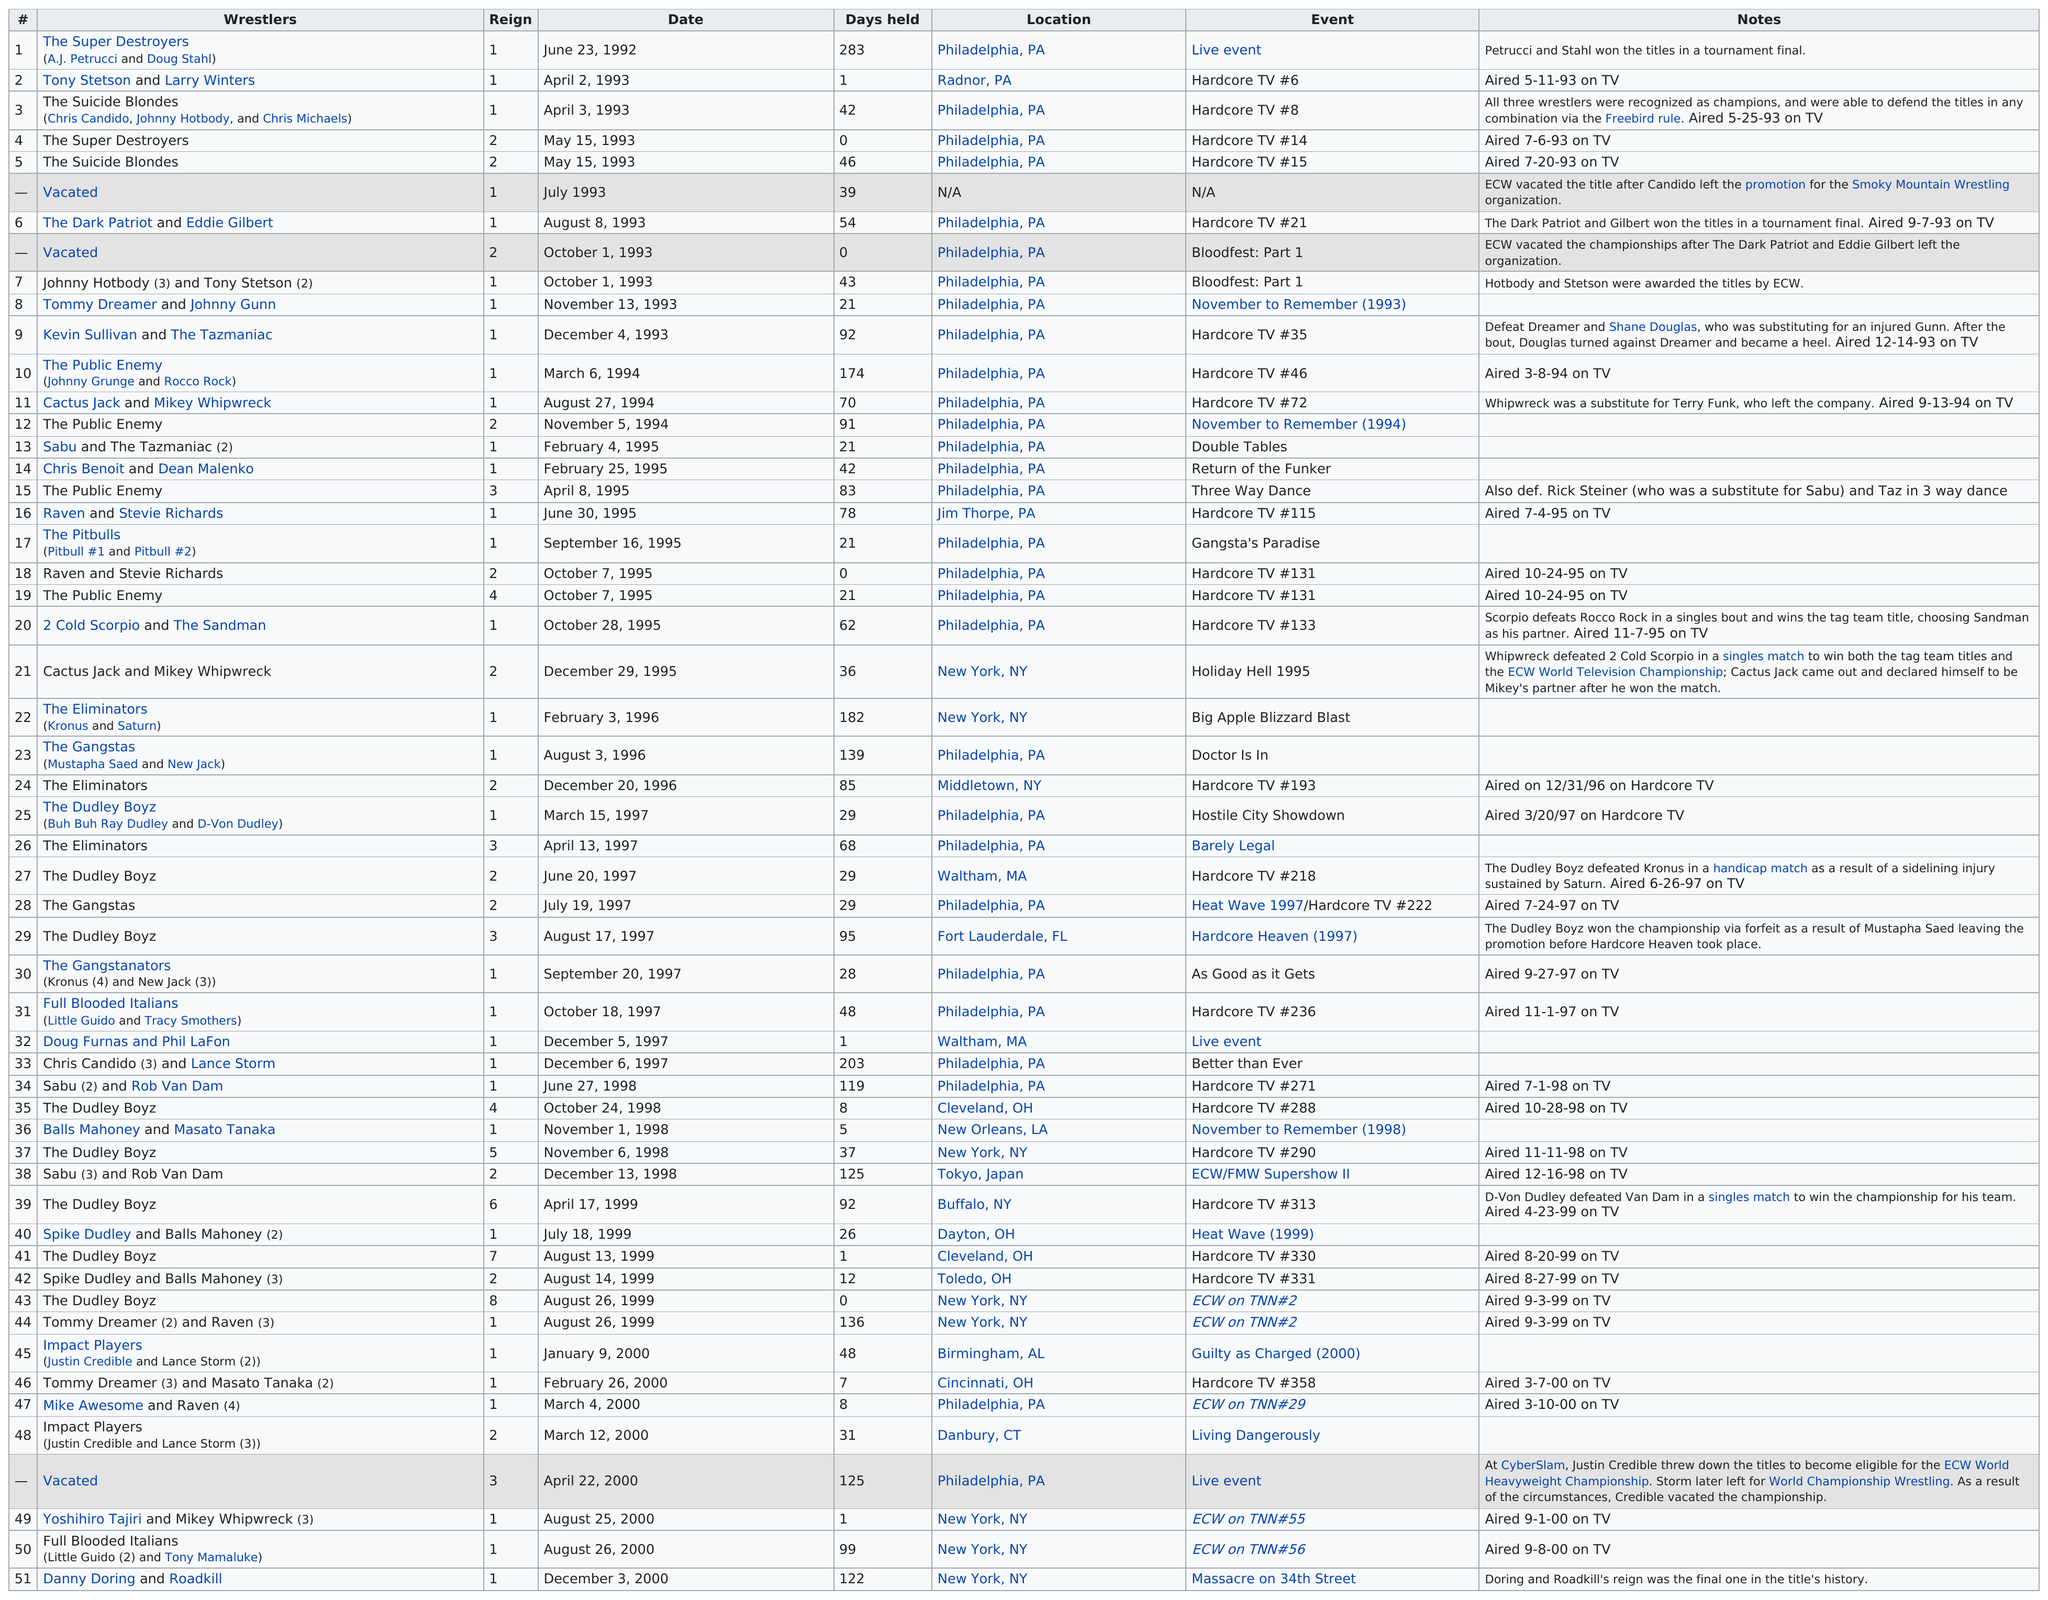Identify some key points in this picture. The Dudley Boyz held the tag team championship title the most times, and they are known as the greatest tag team of all time. Before Hardcore TV #14, there was Hardcore TV #8. The Dudley Boyz were the only team to win by forfeit, making them the only team to achieve victory in such a manner. Before Chris Benoit regained the title on April 8th, 1995, it was previously held by Dean Malenko. The next event in the series of Hardcore TV events is Hardcore TV #21. 